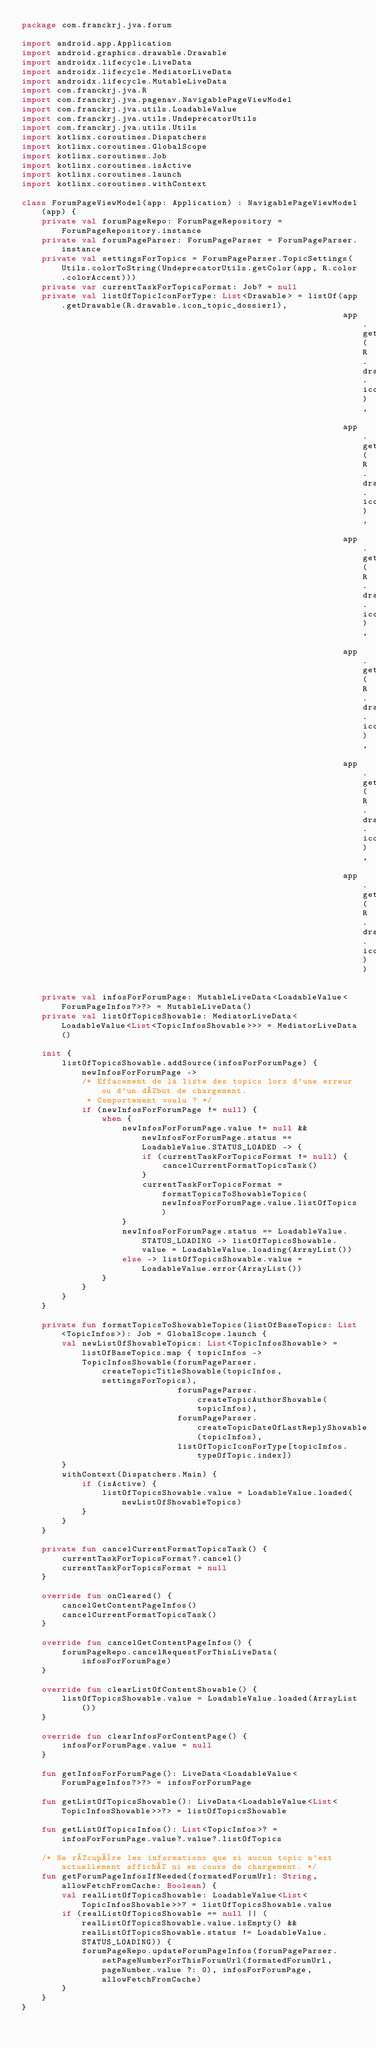Convert code to text. <code><loc_0><loc_0><loc_500><loc_500><_Kotlin_>package com.franckrj.jva.forum

import android.app.Application
import android.graphics.drawable.Drawable
import androidx.lifecycle.LiveData
import androidx.lifecycle.MediatorLiveData
import androidx.lifecycle.MutableLiveData
import com.franckrj.jva.R
import com.franckrj.jva.pagenav.NavigablePageViewModel
import com.franckrj.jva.utils.LoadableValue
import com.franckrj.jva.utils.UndeprecatorUtils
import com.franckrj.jva.utils.Utils
import kotlinx.coroutines.Dispatchers
import kotlinx.coroutines.GlobalScope
import kotlinx.coroutines.Job
import kotlinx.coroutines.isActive
import kotlinx.coroutines.launch
import kotlinx.coroutines.withContext

class ForumPageViewModel(app: Application) : NavigablePageViewModel(app) {
    private val forumPageRepo: ForumPageRepository = ForumPageRepository.instance
    private val forumPageParser: ForumPageParser = ForumPageParser.instance
    private val settingsForTopics = ForumPageParser.TopicSettings(Utils.colorToString(UndeprecatorUtils.getColor(app, R.color.colorAccent)))
    private var currentTaskForTopicsFormat: Job? = null
    private val listOfTopicIconForType: List<Drawable> = listOf(app.getDrawable(R.drawable.icon_topic_dossier1),
                                                                app.getDrawable(R.drawable.icon_topic_dossier2),
                                                                app.getDrawable(R.drawable.icon_topic_lock_light),
                                                                app.getDrawable(R.drawable.icon_topic_marque_on),
                                                                app.getDrawable(R.drawable.icon_topic_marque_off),
                                                                app.getDrawable(R.drawable.icon_topic_ghost),
                                                                app.getDrawable(R.drawable.icon_topic_resolu))

    private val infosForForumPage: MutableLiveData<LoadableValue<ForumPageInfos?>?> = MutableLiveData()
    private val listOfTopicsShowable: MediatorLiveData<LoadableValue<List<TopicInfosShowable>>> = MediatorLiveData()

    init {
        listOfTopicsShowable.addSource(infosForForumPage) { newInfosForForumPage ->
            /* Effacement de la liste des topics lors d'une erreur ou d'un début de chargement.
             * Comportement voulu ? */
            if (newInfosForForumPage != null) {
                when {
                    newInfosForForumPage.value != null && newInfosForForumPage.status == LoadableValue.STATUS_LOADED -> {
                        if (currentTaskForTopicsFormat != null) {
                            cancelCurrentFormatTopicsTask()
                        }
                        currentTaskForTopicsFormat = formatTopicsToShowableTopics(newInfosForForumPage.value.listOfTopics)
                    }
                    newInfosForForumPage.status == LoadableValue.STATUS_LOADING -> listOfTopicsShowable.value = LoadableValue.loading(ArrayList())
                    else -> listOfTopicsShowable.value = LoadableValue.error(ArrayList())
                }
            }
        }
    }

    private fun formatTopicsToShowableTopics(listOfBaseTopics: List<TopicInfos>): Job = GlobalScope.launch {
        val newListOfShowableTopics: List<TopicInfosShowable> = listOfBaseTopics.map { topicInfos ->
            TopicInfosShowable(forumPageParser.createTopicTitleShowable(topicInfos, settingsForTopics),
                               forumPageParser.createTopicAuthorShowable(topicInfos),
                               forumPageParser.createTopicDateOfLastReplyShowable(topicInfos),
                               listOfTopicIconForType[topicInfos.typeOfTopic.index])
        }
        withContext(Dispatchers.Main) {
            if (isActive) {
                listOfTopicsShowable.value = LoadableValue.loaded(newListOfShowableTopics)
            }
        }
    }

    private fun cancelCurrentFormatTopicsTask() {
        currentTaskForTopicsFormat?.cancel()
        currentTaskForTopicsFormat = null
    }

    override fun onCleared() {
        cancelGetContentPageInfos()
        cancelCurrentFormatTopicsTask()
    }

    override fun cancelGetContentPageInfos() {
        forumPageRepo.cancelRequestForThisLiveData(infosForForumPage)
    }

    override fun clearListOfContentShowable() {
        listOfTopicsShowable.value = LoadableValue.loaded(ArrayList())
    }

    override fun clearInfosForContentPage() {
        infosForForumPage.value = null
    }

    fun getInfosForForumPage(): LiveData<LoadableValue<ForumPageInfos?>?> = infosForForumPage

    fun getListOfTopicsShowable(): LiveData<LoadableValue<List<TopicInfosShowable>>?> = listOfTopicsShowable

    fun getListOfTopicsInfos(): List<TopicInfos>? = infosForForumPage.value?.value?.listOfTopics

    /* Ne récupère les informations que si aucun topic n'est actuellement affiché ni en cours de chargement. */
    fun getForumPageInfosIfNeeded(formatedForumUrl: String, allowFetchFromCache: Boolean) {
        val realListOfTopicsShowable: LoadableValue<List<TopicInfosShowable>>? = listOfTopicsShowable.value
        if (realListOfTopicsShowable == null || (realListOfTopicsShowable.value.isEmpty() && realListOfTopicsShowable.status != LoadableValue.STATUS_LOADING)) {
            forumPageRepo.updateForumPageInfos(forumPageParser.setPageNumberForThisForumUrl(formatedForumUrl, pageNumber.value ?: 0), infosForForumPage, allowFetchFromCache)
        }
    }
}
</code> 